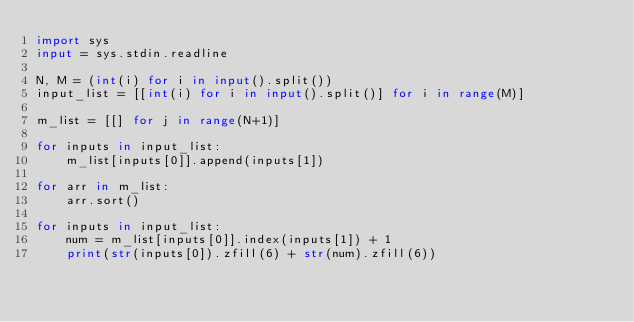<code> <loc_0><loc_0><loc_500><loc_500><_Python_>import sys
input = sys.stdin.readline
 
N, M = (int(i) for i in input().split())
input_list = [[int(i) for i in input().split()] for i in range(M)] 
 
m_list = [[] for j in range(N+1)]
 
for inputs in input_list:
    m_list[inputs[0]].append(inputs[1])
 
for arr in m_list:
    arr.sort()
 
for inputs in input_list:
    num = m_list[inputs[0]].index(inputs[1]) + 1
    print(str(inputs[0]).zfill(6) + str(num).zfill(6))</code> 